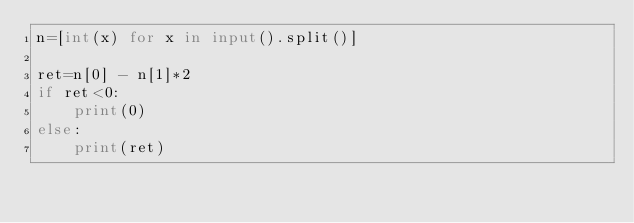<code> <loc_0><loc_0><loc_500><loc_500><_Python_>n=[int(x) for x in input().split()]

ret=n[0] - n[1]*2
if ret<0:
    print(0)
else:
    print(ret)</code> 